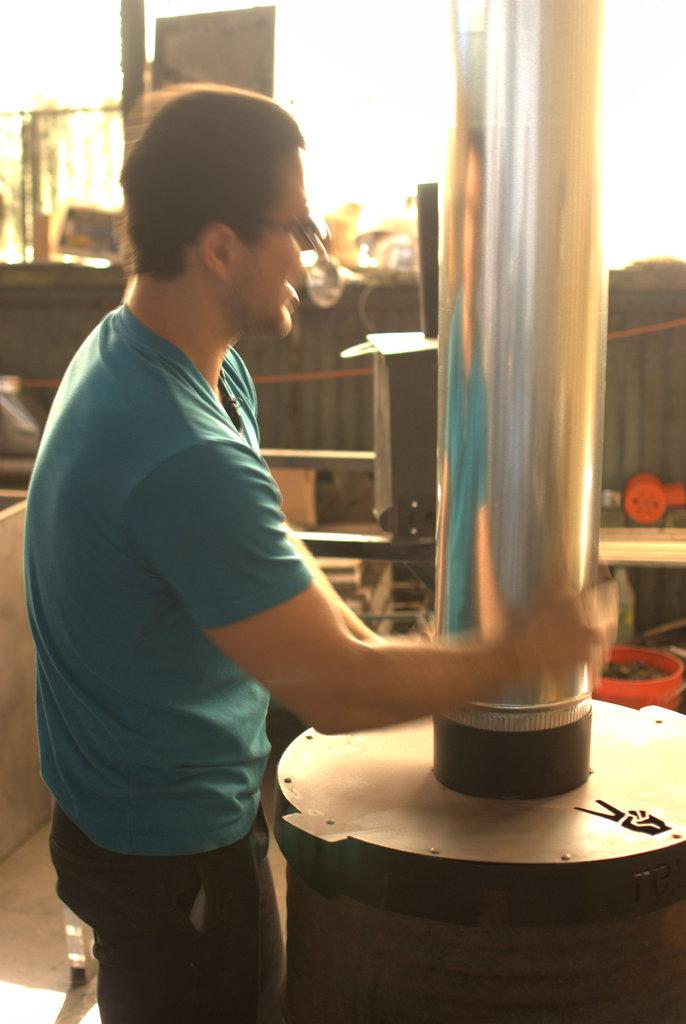What is the main subject of the image? There is a man standing in the image. What is the man holding in the image? The man is holding a silver pipe. Can you describe the background of the image? There are objects in the background of the image. What type of instrument is the fireman playing in the image? There is no fireman or instrument present in the image. What is the man's hope for the future, as depicted in the image? The image does not provide any information about the man's hopes or aspirations. 